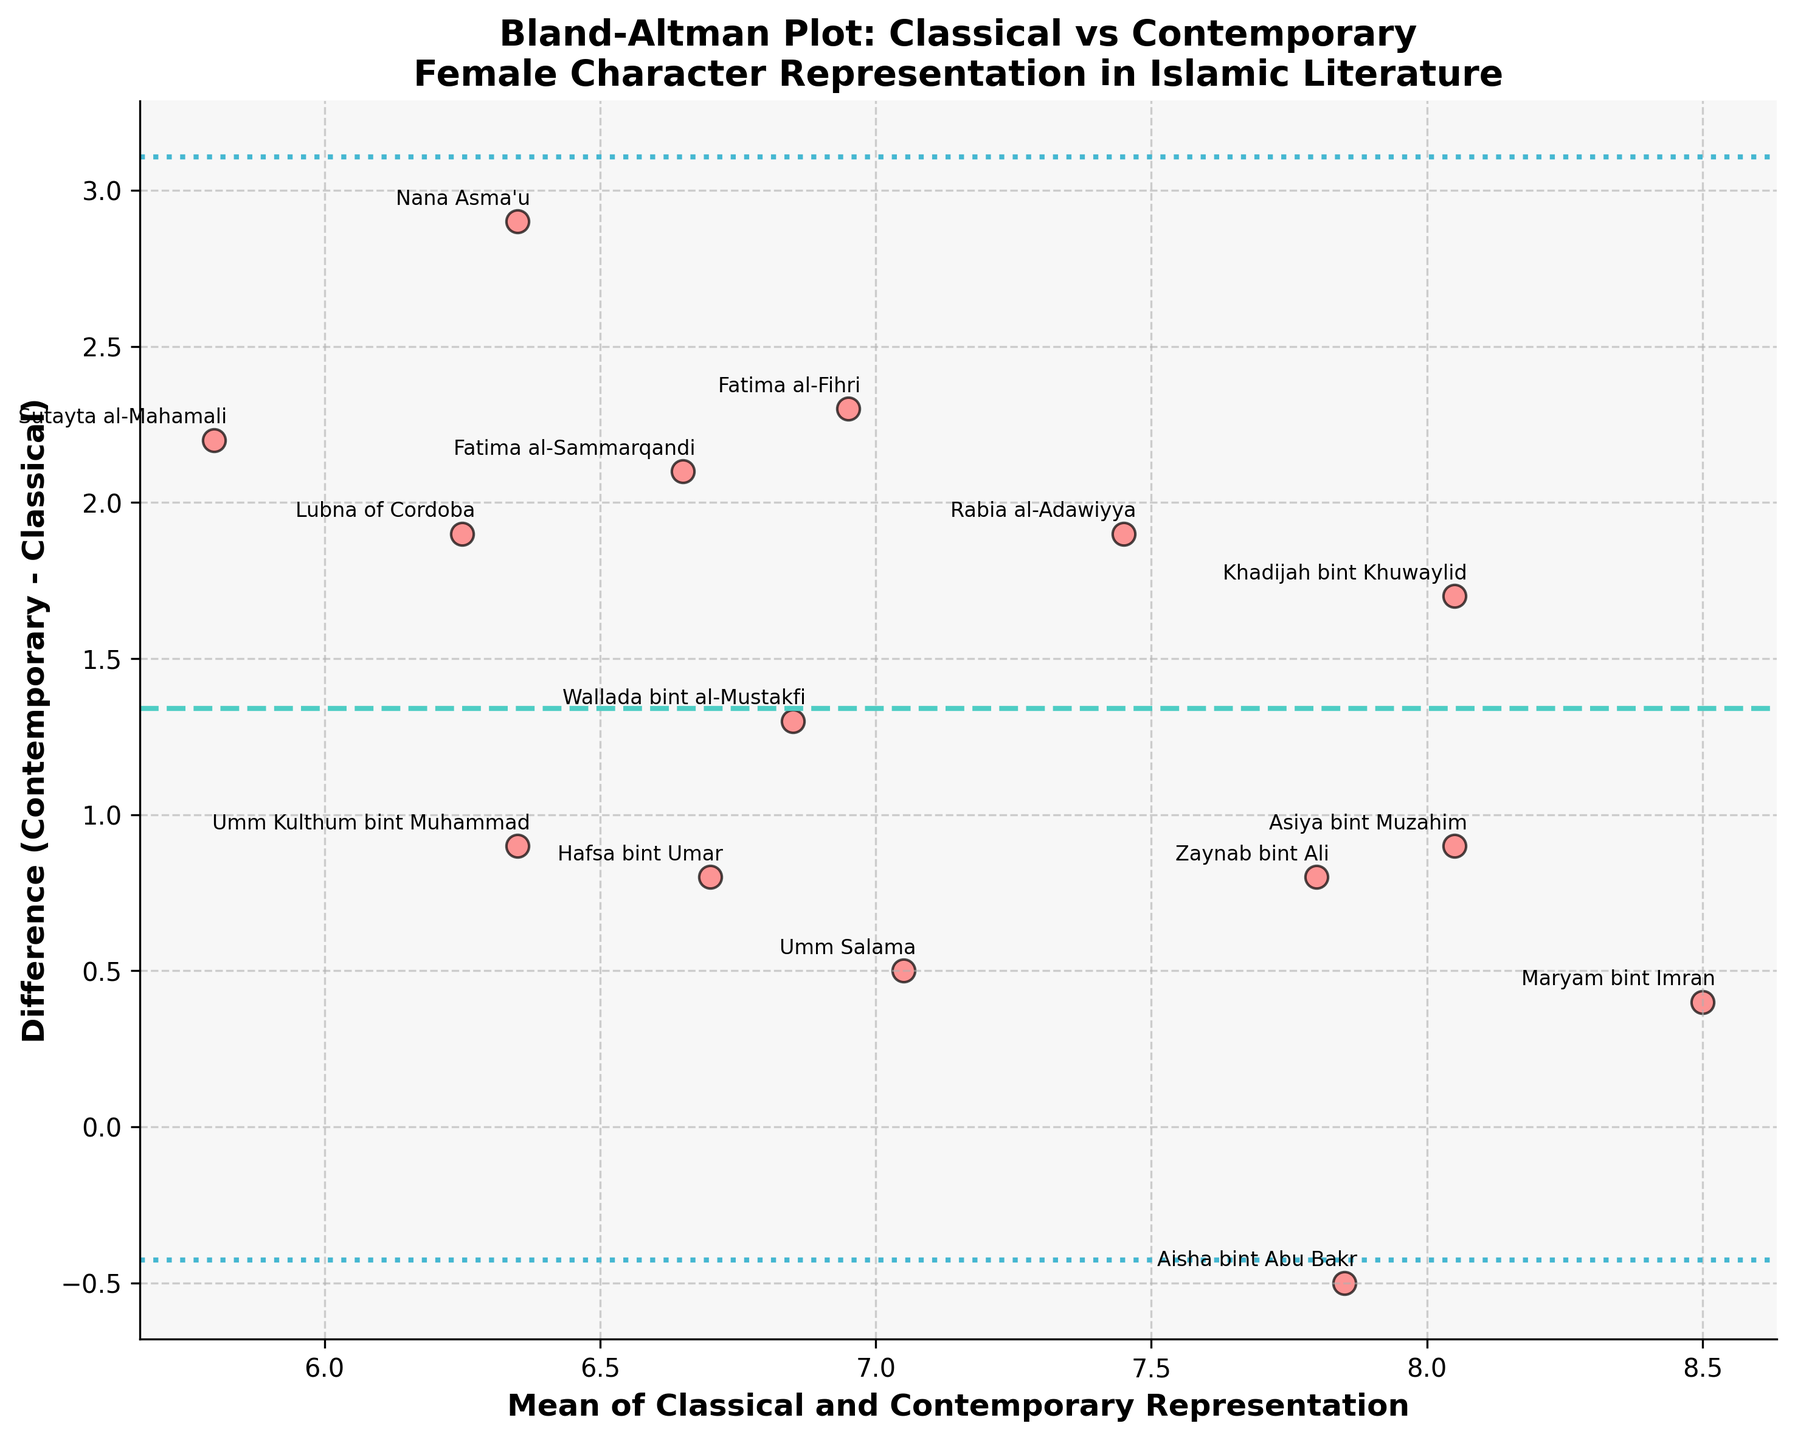What is the title of the figure? The title of the figure can be found at the top of the plot. It reads "Bland-Altman Plot: Classical vs Contemporary Female Character Representation in Islamic Literature".
Answer: Bland-Altman Plot: Classical vs Contemporary Female Character Representation in Islamic Literature How many data points are there in the figure? Each character's representation is marked by a scatter point, and there are 15 distinct characters identified in the data and plot.
Answer: 15 Which character has the maximum difference in representation between classical and contemporary literature? By examining the scatter points, Maryam bint Imran has the smallest difference, close to the lower boundary line, indicating she has the maximum difference.
Answer: Maryam bint Imran What does the dotted line in the middle of the plot represent? The dotted line represents the mean difference between the contemporary and classical representations. This is the average of the vertical differences of all points.
Answer: Mean difference What is the color of the points in the plot? The points in the figure are depicted in a pinkish-red color, making them stand out against the background.
Answer: Pinkish-red Which character has the highest average representation across both classical and contemporary literature? Examining the scatter points, the character with the highest average is the closest to the rightmost part of the x-axis. Maryam bint Imran is the point furthest on the right.
Answer: Maryam bint Imran What are the two dotted lines above and below the mean difference line? These lines represent the limits of agreement, which are the mean difference plus and minus 1.96 times the standard deviation.
Answer: Limits of agreement Is the difference between classical and contemporary representations more often positive or negative? Observing the scatter points, the majority are primarily above the mean difference line, indicating more often the differences are positive.
Answer: Positive Between Khadijah bint Khuwaylid and Aisha bint Abu Bakr, which character has a greater increase in representation in contemporary literature? Khadijah bint Khuwaylid’s difference appears above zero on the y-axis, whereas Aisha bint Abu Bakr’s point is below zero. Thus, Khadijah has a greater increase.
Answer: Khadijah bint Khuwaylid 